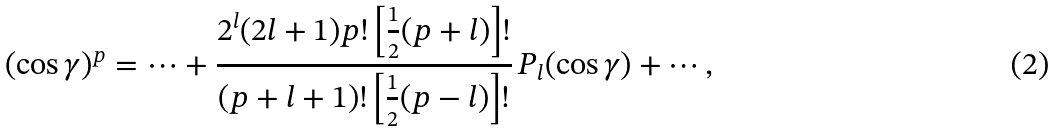Convert formula to latex. <formula><loc_0><loc_0><loc_500><loc_500>( \cos \gamma ) ^ { p } = \cdots + \frac { 2 ^ { l } ( 2 l + 1 ) p ! \left [ \frac { 1 } { 2 } ( p + l ) \right ] ! } { ( p + l + 1 ) ! \left [ \frac { 1 } { 2 } ( p - l ) \right ] ! } \, P _ { l } ( \cos \gamma ) + \cdots ,</formula> 